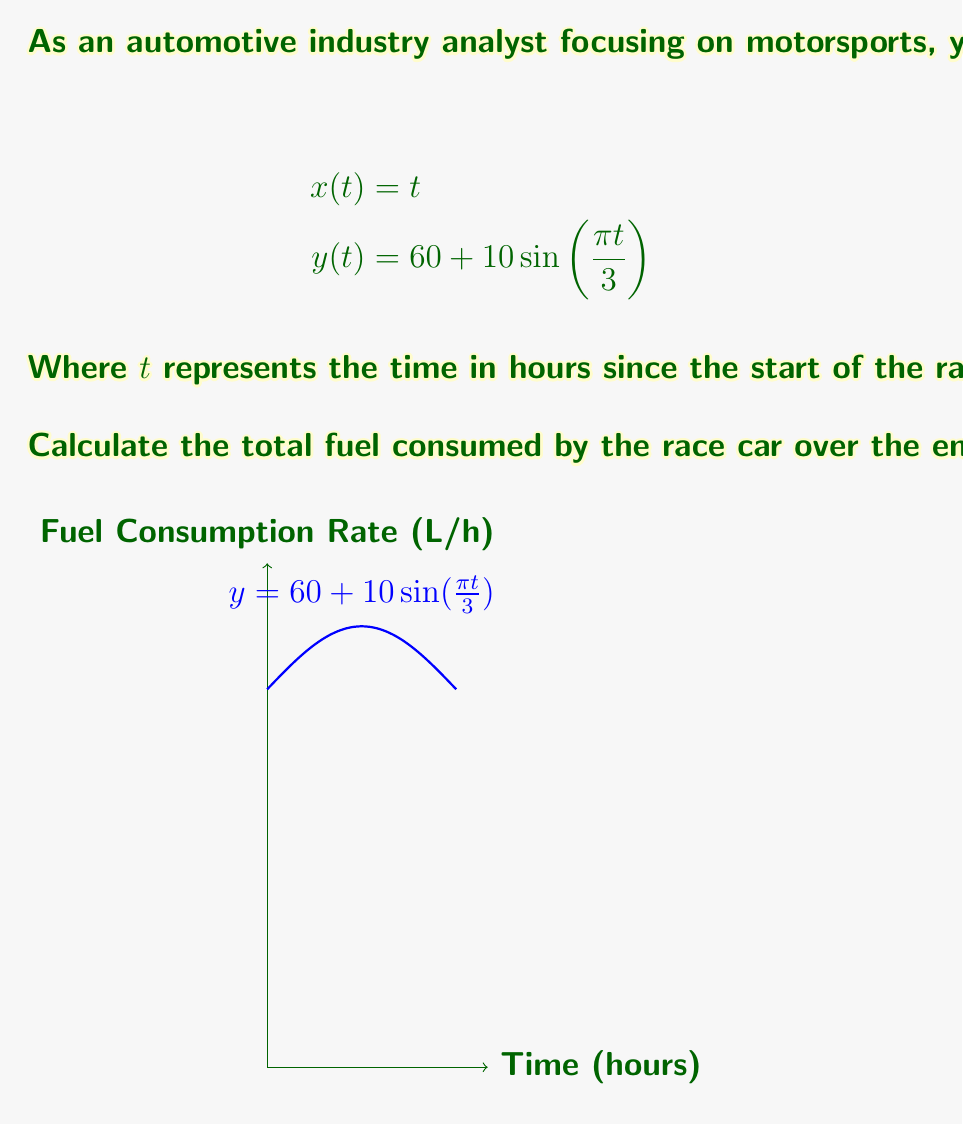Teach me how to tackle this problem. To solve this problem, we need to calculate the integral of the fuel consumption rate over the given time period. Here's a step-by-step approach:

1) The fuel consumption rate is given by $y(t) = 60 + 10\sin(\frac{\pi t}{3})$.

2) To find the total fuel consumed, we need to integrate this function from t = 0 to t = 3:

   $$\int_0^3 (60 + 10\sin(\frac{\pi t}{3})) dt$$

3) Let's break this integral into two parts:
   
   $$\int_0^3 60 dt + \int_0^3 10\sin(\frac{\pi t}{3}) dt$$

4) For the first part:
   
   $$\int_0^3 60 dt = 60t \bigg|_0^3 = 60 \cdot 3 - 60 \cdot 0 = 180$$

5) For the second part, we use the substitution method:
   Let $u = \frac{\pi t}{3}$, then $du = \frac{\pi}{3} dt$ or $dt = \frac{3}{\pi} du$
   
   When $t = 0$, $u = 0$; when $t = 3$, $u = \pi$

   $$\int_0^3 10\sin(\frac{\pi t}{3}) dt = 10 \cdot \frac{3}{\pi} \int_0^\pi \sin(u) du$$

6) Solving this integral:

   $$10 \cdot \frac{3}{\pi} [-\cos(u)]_0^\pi = 10 \cdot \frac{3}{\pi} [(-\cos(\pi)) - (-\cos(0))]$$
   $$= 10 \cdot \frac{3}{\pi} [(1) - (-1)] = \frac{60}{\pi}$$

7) Adding the results from steps 4 and 6:

   Total fuel consumed = $180 + \frac{60}{\pi}$ liters
Answer: $180 + \frac{60}{\pi}$ liters 